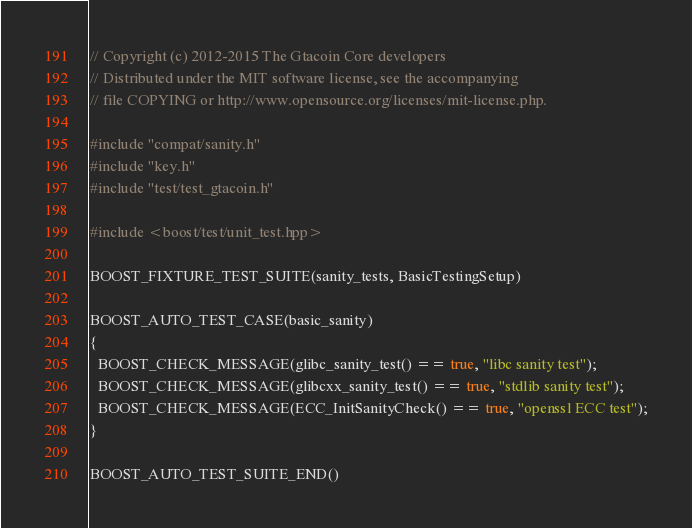<code> <loc_0><loc_0><loc_500><loc_500><_C++_>// Copyright (c) 2012-2015 The Gtacoin Core developers
// Distributed under the MIT software license, see the accompanying
// file COPYING or http://www.opensource.org/licenses/mit-license.php.

#include "compat/sanity.h"
#include "key.h"
#include "test/test_gtacoin.h"

#include <boost/test/unit_test.hpp>

BOOST_FIXTURE_TEST_SUITE(sanity_tests, BasicTestingSetup)

BOOST_AUTO_TEST_CASE(basic_sanity)
{
  BOOST_CHECK_MESSAGE(glibc_sanity_test() == true, "libc sanity test");
  BOOST_CHECK_MESSAGE(glibcxx_sanity_test() == true, "stdlib sanity test");
  BOOST_CHECK_MESSAGE(ECC_InitSanityCheck() == true, "openssl ECC test");
}

BOOST_AUTO_TEST_SUITE_END()
</code> 